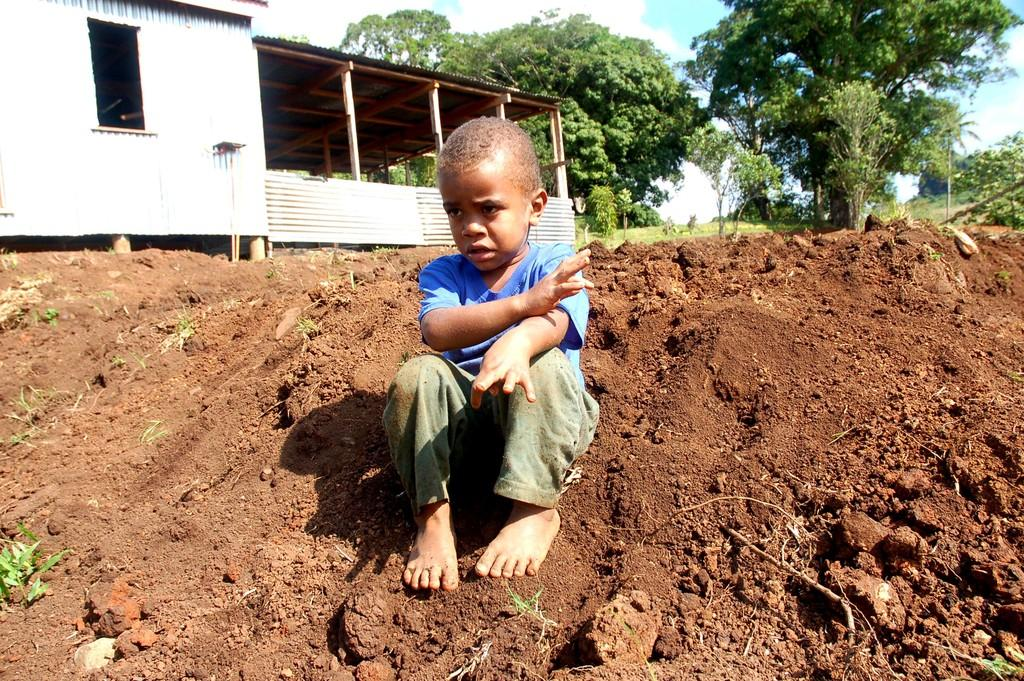What is the main subject of the image? The main subject of the image is a kid. Where is the kid sitting in the image? The kid is sitting on soil. What can be seen in the background of the image? There is a shed and trees in the background of the image. What type of sock is the kid wearing in the image? There is no sock visible in the image, as the kid is sitting on soil and wearing no footwear. 